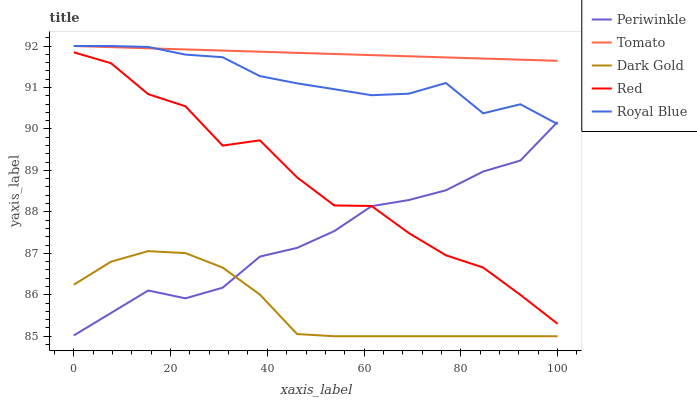Does Dark Gold have the minimum area under the curve?
Answer yes or no. Yes. Does Tomato have the maximum area under the curve?
Answer yes or no. Yes. Does Royal Blue have the minimum area under the curve?
Answer yes or no. No. Does Royal Blue have the maximum area under the curve?
Answer yes or no. No. Is Tomato the smoothest?
Answer yes or no. Yes. Is Red the roughest?
Answer yes or no. Yes. Is Royal Blue the smoothest?
Answer yes or no. No. Is Royal Blue the roughest?
Answer yes or no. No. Does Dark Gold have the lowest value?
Answer yes or no. Yes. Does Royal Blue have the lowest value?
Answer yes or no. No. Does Royal Blue have the highest value?
Answer yes or no. Yes. Does Periwinkle have the highest value?
Answer yes or no. No. Is Dark Gold less than Red?
Answer yes or no. Yes. Is Tomato greater than Periwinkle?
Answer yes or no. Yes. Does Royal Blue intersect Periwinkle?
Answer yes or no. Yes. Is Royal Blue less than Periwinkle?
Answer yes or no. No. Is Royal Blue greater than Periwinkle?
Answer yes or no. No. Does Dark Gold intersect Red?
Answer yes or no. No. 